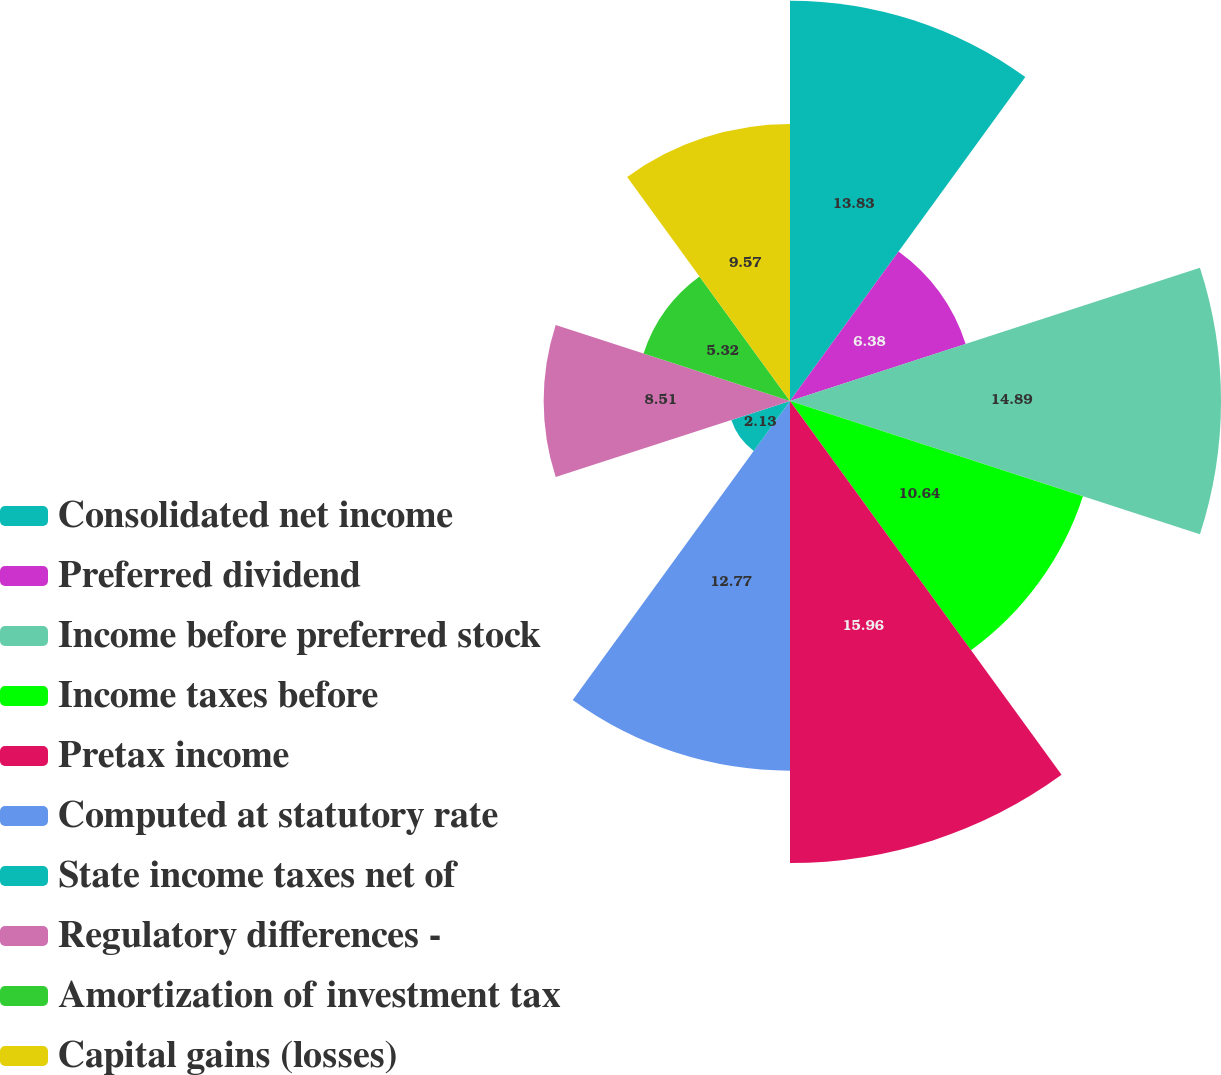Convert chart to OTSL. <chart><loc_0><loc_0><loc_500><loc_500><pie_chart><fcel>Consolidated net income<fcel>Preferred dividend<fcel>Income before preferred stock<fcel>Income taxes before<fcel>Pretax income<fcel>Computed at statutory rate<fcel>State income taxes net of<fcel>Regulatory differences -<fcel>Amortization of investment tax<fcel>Capital gains (losses)<nl><fcel>13.83%<fcel>6.38%<fcel>14.89%<fcel>10.64%<fcel>15.96%<fcel>12.77%<fcel>2.13%<fcel>8.51%<fcel>5.32%<fcel>9.57%<nl></chart> 